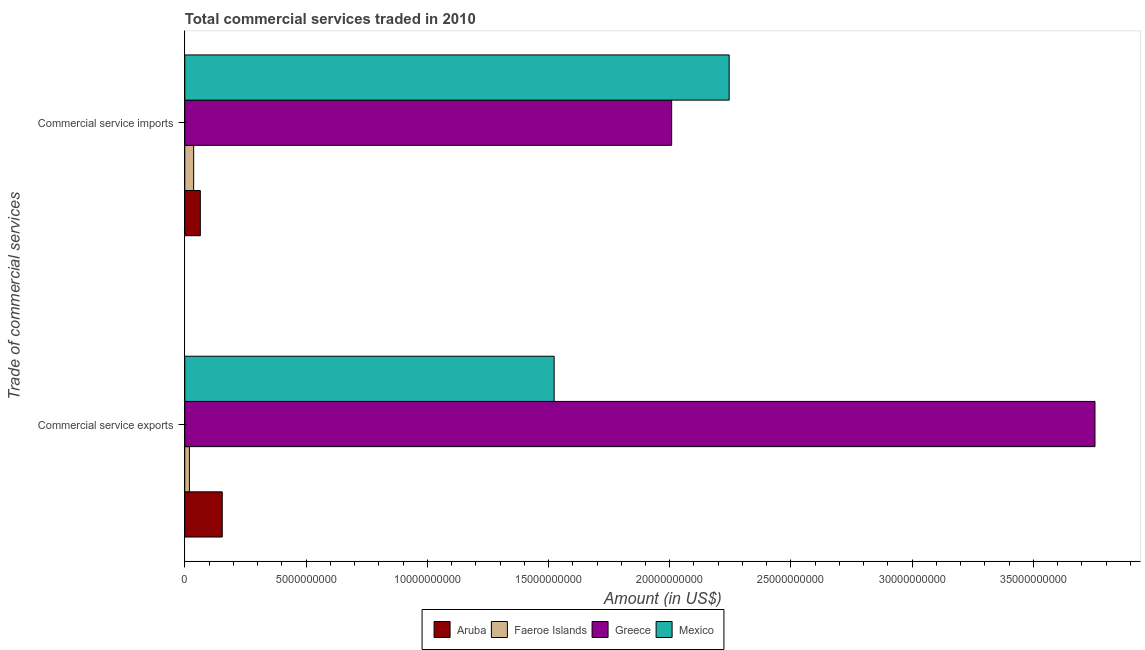Are the number of bars on each tick of the Y-axis equal?
Your answer should be very brief. Yes. How many bars are there on the 1st tick from the top?
Your answer should be very brief. 4. How many bars are there on the 1st tick from the bottom?
Ensure brevity in your answer.  4. What is the label of the 1st group of bars from the top?
Your response must be concise. Commercial service imports. What is the amount of commercial service exports in Mexico?
Provide a short and direct response. 1.52e+1. Across all countries, what is the maximum amount of commercial service exports?
Your response must be concise. 3.75e+1. Across all countries, what is the minimum amount of commercial service exports?
Your response must be concise. 1.91e+08. In which country was the amount of commercial service imports maximum?
Your response must be concise. Mexico. In which country was the amount of commercial service imports minimum?
Provide a short and direct response. Faeroe Islands. What is the total amount of commercial service exports in the graph?
Provide a short and direct response. 5.45e+1. What is the difference between the amount of commercial service imports in Aruba and that in Mexico?
Ensure brevity in your answer.  -2.18e+1. What is the difference between the amount of commercial service imports in Faeroe Islands and the amount of commercial service exports in Mexico?
Make the answer very short. -1.49e+1. What is the average amount of commercial service imports per country?
Your answer should be very brief. 1.09e+1. What is the difference between the amount of commercial service exports and amount of commercial service imports in Greece?
Provide a short and direct response. 1.75e+1. What is the ratio of the amount of commercial service imports in Mexico to that in Aruba?
Provide a succinct answer. 35.03. Is the amount of commercial service imports in Greece less than that in Aruba?
Your answer should be very brief. No. What does the 1st bar from the bottom in Commercial service imports represents?
Make the answer very short. Aruba. How many bars are there?
Provide a succinct answer. 8. How many countries are there in the graph?
Provide a short and direct response. 4. What is the difference between two consecutive major ticks on the X-axis?
Your response must be concise. 5.00e+09. Are the values on the major ticks of X-axis written in scientific E-notation?
Keep it short and to the point. No. How many legend labels are there?
Offer a very short reply. 4. How are the legend labels stacked?
Ensure brevity in your answer.  Horizontal. What is the title of the graph?
Your answer should be very brief. Total commercial services traded in 2010. Does "Madagascar" appear as one of the legend labels in the graph?
Provide a succinct answer. No. What is the label or title of the Y-axis?
Offer a terse response. Trade of commercial services. What is the Amount (in US$) in Aruba in Commercial service exports?
Ensure brevity in your answer.  1.55e+09. What is the Amount (in US$) in Faeroe Islands in Commercial service exports?
Make the answer very short. 1.91e+08. What is the Amount (in US$) of Greece in Commercial service exports?
Provide a succinct answer. 3.75e+1. What is the Amount (in US$) in Mexico in Commercial service exports?
Ensure brevity in your answer.  1.52e+1. What is the Amount (in US$) in Aruba in Commercial service imports?
Ensure brevity in your answer.  6.41e+08. What is the Amount (in US$) of Faeroe Islands in Commercial service imports?
Provide a succinct answer. 3.66e+08. What is the Amount (in US$) in Greece in Commercial service imports?
Keep it short and to the point. 2.01e+1. What is the Amount (in US$) in Mexico in Commercial service imports?
Your response must be concise. 2.25e+1. Across all Trade of commercial services, what is the maximum Amount (in US$) in Aruba?
Give a very brief answer. 1.55e+09. Across all Trade of commercial services, what is the maximum Amount (in US$) in Faeroe Islands?
Your response must be concise. 3.66e+08. Across all Trade of commercial services, what is the maximum Amount (in US$) of Greece?
Your answer should be very brief. 3.75e+1. Across all Trade of commercial services, what is the maximum Amount (in US$) of Mexico?
Provide a succinct answer. 2.25e+1. Across all Trade of commercial services, what is the minimum Amount (in US$) of Aruba?
Your answer should be very brief. 6.41e+08. Across all Trade of commercial services, what is the minimum Amount (in US$) in Faeroe Islands?
Your response must be concise. 1.91e+08. Across all Trade of commercial services, what is the minimum Amount (in US$) of Greece?
Keep it short and to the point. 2.01e+1. Across all Trade of commercial services, what is the minimum Amount (in US$) of Mexico?
Keep it short and to the point. 1.52e+1. What is the total Amount (in US$) in Aruba in the graph?
Provide a succinct answer. 2.19e+09. What is the total Amount (in US$) in Faeroe Islands in the graph?
Offer a terse response. 5.57e+08. What is the total Amount (in US$) of Greece in the graph?
Your answer should be very brief. 5.76e+1. What is the total Amount (in US$) in Mexico in the graph?
Your answer should be compact. 3.77e+1. What is the difference between the Amount (in US$) of Aruba in Commercial service exports and that in Commercial service imports?
Your response must be concise. 9.04e+08. What is the difference between the Amount (in US$) of Faeroe Islands in Commercial service exports and that in Commercial service imports?
Provide a succinct answer. -1.75e+08. What is the difference between the Amount (in US$) of Greece in Commercial service exports and that in Commercial service imports?
Keep it short and to the point. 1.75e+1. What is the difference between the Amount (in US$) in Mexico in Commercial service exports and that in Commercial service imports?
Your answer should be very brief. -7.22e+09. What is the difference between the Amount (in US$) in Aruba in Commercial service exports and the Amount (in US$) in Faeroe Islands in Commercial service imports?
Keep it short and to the point. 1.18e+09. What is the difference between the Amount (in US$) in Aruba in Commercial service exports and the Amount (in US$) in Greece in Commercial service imports?
Provide a short and direct response. -1.85e+1. What is the difference between the Amount (in US$) in Aruba in Commercial service exports and the Amount (in US$) in Mexico in Commercial service imports?
Offer a terse response. -2.09e+1. What is the difference between the Amount (in US$) of Faeroe Islands in Commercial service exports and the Amount (in US$) of Greece in Commercial service imports?
Your answer should be compact. -1.99e+1. What is the difference between the Amount (in US$) in Faeroe Islands in Commercial service exports and the Amount (in US$) in Mexico in Commercial service imports?
Give a very brief answer. -2.23e+1. What is the difference between the Amount (in US$) of Greece in Commercial service exports and the Amount (in US$) of Mexico in Commercial service imports?
Offer a terse response. 1.51e+1. What is the average Amount (in US$) of Aruba per Trade of commercial services?
Offer a terse response. 1.09e+09. What is the average Amount (in US$) of Faeroe Islands per Trade of commercial services?
Ensure brevity in your answer.  2.78e+08. What is the average Amount (in US$) of Greece per Trade of commercial services?
Offer a very short reply. 2.88e+1. What is the average Amount (in US$) in Mexico per Trade of commercial services?
Offer a terse response. 1.88e+1. What is the difference between the Amount (in US$) of Aruba and Amount (in US$) of Faeroe Islands in Commercial service exports?
Offer a very short reply. 1.35e+09. What is the difference between the Amount (in US$) of Aruba and Amount (in US$) of Greece in Commercial service exports?
Your answer should be very brief. -3.60e+1. What is the difference between the Amount (in US$) in Aruba and Amount (in US$) in Mexico in Commercial service exports?
Provide a short and direct response. -1.37e+1. What is the difference between the Amount (in US$) of Faeroe Islands and Amount (in US$) of Greece in Commercial service exports?
Your response must be concise. -3.73e+1. What is the difference between the Amount (in US$) in Faeroe Islands and Amount (in US$) in Mexico in Commercial service exports?
Your answer should be compact. -1.50e+1. What is the difference between the Amount (in US$) of Greece and Amount (in US$) of Mexico in Commercial service exports?
Your response must be concise. 2.23e+1. What is the difference between the Amount (in US$) of Aruba and Amount (in US$) of Faeroe Islands in Commercial service imports?
Your answer should be very brief. 2.75e+08. What is the difference between the Amount (in US$) of Aruba and Amount (in US$) of Greece in Commercial service imports?
Keep it short and to the point. -1.94e+1. What is the difference between the Amount (in US$) of Aruba and Amount (in US$) of Mexico in Commercial service imports?
Ensure brevity in your answer.  -2.18e+1. What is the difference between the Amount (in US$) of Faeroe Islands and Amount (in US$) of Greece in Commercial service imports?
Offer a terse response. -1.97e+1. What is the difference between the Amount (in US$) in Faeroe Islands and Amount (in US$) in Mexico in Commercial service imports?
Keep it short and to the point. -2.21e+1. What is the difference between the Amount (in US$) in Greece and Amount (in US$) in Mexico in Commercial service imports?
Provide a succinct answer. -2.37e+09. What is the ratio of the Amount (in US$) of Aruba in Commercial service exports to that in Commercial service imports?
Ensure brevity in your answer.  2.41. What is the ratio of the Amount (in US$) in Faeroe Islands in Commercial service exports to that in Commercial service imports?
Your answer should be very brief. 0.52. What is the ratio of the Amount (in US$) in Greece in Commercial service exports to that in Commercial service imports?
Offer a very short reply. 1.87. What is the ratio of the Amount (in US$) of Mexico in Commercial service exports to that in Commercial service imports?
Your answer should be compact. 0.68. What is the difference between the highest and the second highest Amount (in US$) in Aruba?
Give a very brief answer. 9.04e+08. What is the difference between the highest and the second highest Amount (in US$) in Faeroe Islands?
Offer a very short reply. 1.75e+08. What is the difference between the highest and the second highest Amount (in US$) of Greece?
Your response must be concise. 1.75e+1. What is the difference between the highest and the second highest Amount (in US$) in Mexico?
Offer a terse response. 7.22e+09. What is the difference between the highest and the lowest Amount (in US$) of Aruba?
Offer a terse response. 9.04e+08. What is the difference between the highest and the lowest Amount (in US$) of Faeroe Islands?
Offer a very short reply. 1.75e+08. What is the difference between the highest and the lowest Amount (in US$) of Greece?
Your response must be concise. 1.75e+1. What is the difference between the highest and the lowest Amount (in US$) in Mexico?
Offer a terse response. 7.22e+09. 